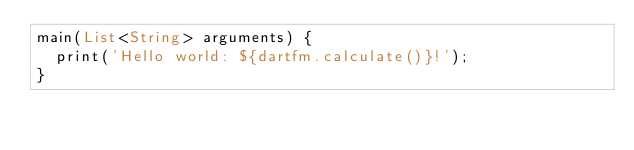<code> <loc_0><loc_0><loc_500><loc_500><_Dart_>main(List<String> arguments) {
  print('Hello world: ${dartfm.calculate()}!');
}
</code> 